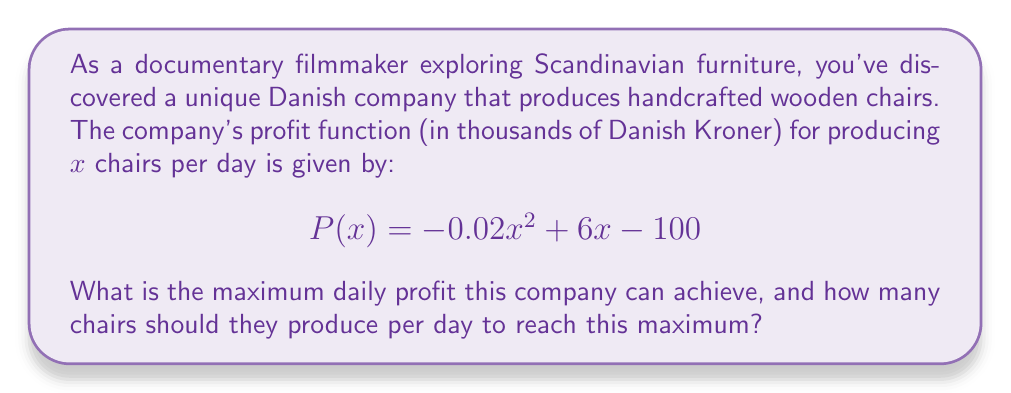Teach me how to tackle this problem. To solve this problem, we'll follow these steps:

1) The profit function $P(x)$ is a quadratic function. To find its maximum, we need to find the vertex of the parabola.

2) For a quadratic function in the form $f(x) = ax^2 + bx + c$, the x-coordinate of the vertex is given by $x = -\frac{b}{2a}$.

3) In our case, $a = -0.02$, $b = 6$, and $c = -100$. Let's calculate the x-coordinate:

   $$x = -\frac{6}{2(-0.02)} = -\frac{6}{-0.04} = 150$$

4) This means the company should produce 150 chairs per day to maximize profit.

5) To find the maximum profit, we substitute $x = 150$ into the original function:

   $$P(150) = -0.02(150)^2 + 6(150) - 100$$
   $$= -0.02(22500) + 900 - 100$$
   $$= -450 + 900 - 100$$
   $$= 350$$

6) Therefore, the maximum daily profit is 350 thousand Danish Kroner.
Answer: Maximum profit: 350,000 DKK; Optimal production: 150 chairs/day 